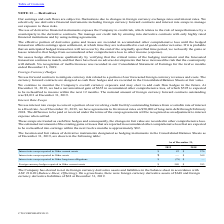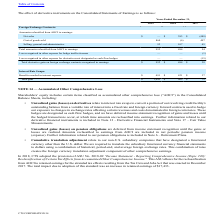From Cts Corporation's financial document, Which years does the table provide information for the  effect of derivative instruments on the Consolidated Statements of Earnings? The document contains multiple relevant values: 2019, 2018, 2017. From the document: "2019 2018 2017 2019 2018 2017 2019 2018 2017..." Also, What were the net sales in 2018? According to the financial document, 383 (in thousands). The relevant text states: "Net sales $ — $ 383 $ (488)..." Also, What was the Cost of goods sold in 2017? According to the financial document, 497 (in thousands). The relevant text states: "Cost of goods sold 860 (6) 497..." Also, can you calculate: What was the change in the Net sales between 2017 and 2018? Based on the calculation: 383-(-488), the result is 871 (in thousands). This is based on the information: "Net sales $ — $ 383 $ (488) Net sales $ — $ 383 $ (488)..." The key data points involved are: 383, 488. Also, can you calculate: What was the change in the Selling, general and administrative between 2018 and 2019? Based on the calculation: 92-107, the result is -15 (in thousands). This is based on the information: "Selling, general and administrative 92 107 45 Selling, general and administrative 92 107 45..." The key data points involved are: 107, 92. Also, can you calculate: What was percentage change in the total gain between 2018 and 2019? To answer this question, I need to perform calculations using the financial data. The calculation is: (1,443-905)/905, which equals 59.45 (percentage). This is based on the information: "Total gain $ 1,443 $ 905 $ 75 Total gain $ 1,443 $ 905 $ 75..." The key data points involved are: 1,443, 905. 